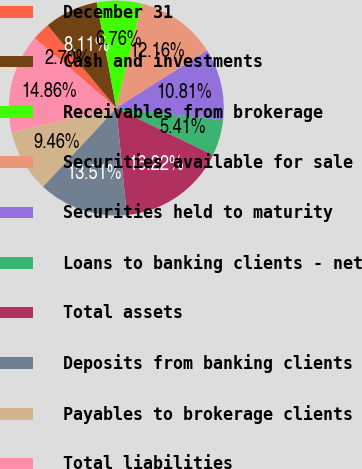Convert chart to OTSL. <chart><loc_0><loc_0><loc_500><loc_500><pie_chart><fcel>December 31<fcel>Cash and investments<fcel>Receivables from brokerage<fcel>Securities available for sale<fcel>Securities held to maturity<fcel>Loans to banking clients - net<fcel>Total assets<fcel>Deposits from banking clients<fcel>Payables to brokerage clients<fcel>Total liabilities<nl><fcel>2.7%<fcel>8.11%<fcel>6.76%<fcel>12.16%<fcel>10.81%<fcel>5.41%<fcel>16.22%<fcel>13.51%<fcel>9.46%<fcel>14.86%<nl></chart> 